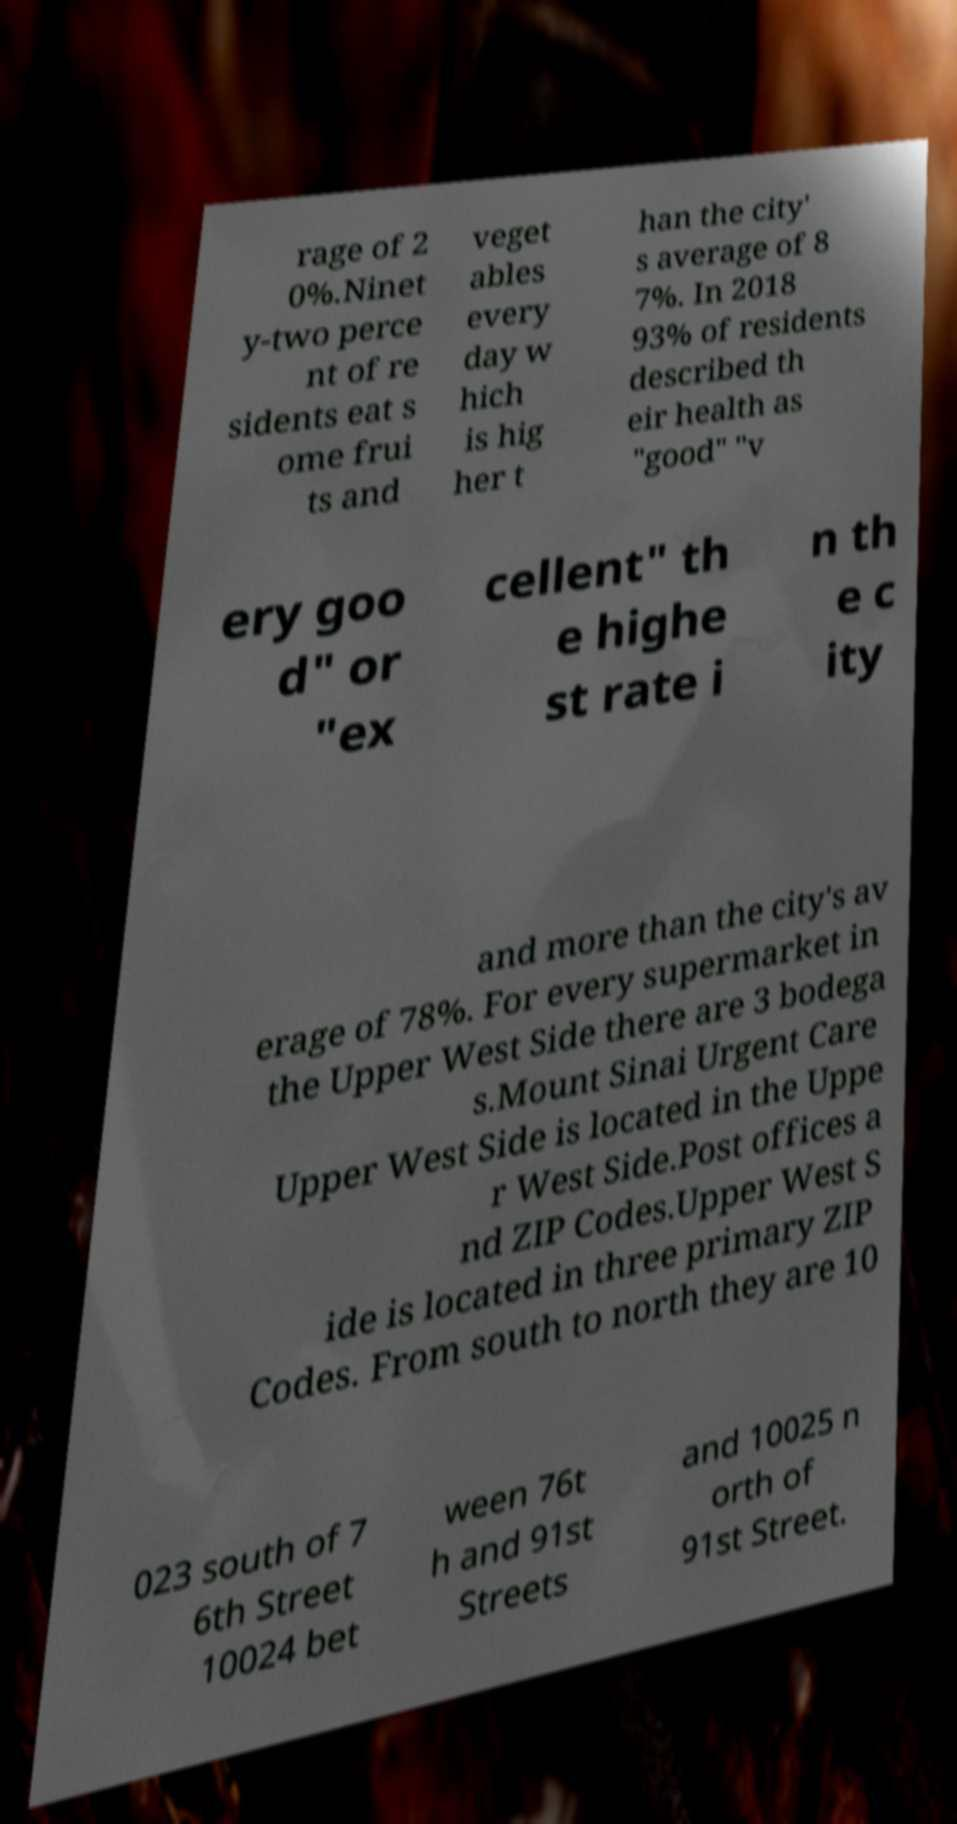What messages or text are displayed in this image? I need them in a readable, typed format. rage of 2 0%.Ninet y-two perce nt of re sidents eat s ome frui ts and veget ables every day w hich is hig her t han the city' s average of 8 7%. In 2018 93% of residents described th eir health as "good" "v ery goo d" or "ex cellent" th e highe st rate i n th e c ity and more than the city's av erage of 78%. For every supermarket in the Upper West Side there are 3 bodega s.Mount Sinai Urgent Care Upper West Side is located in the Uppe r West Side.Post offices a nd ZIP Codes.Upper West S ide is located in three primary ZIP Codes. From south to north they are 10 023 south of 7 6th Street 10024 bet ween 76t h and 91st Streets and 10025 n orth of 91st Street. 